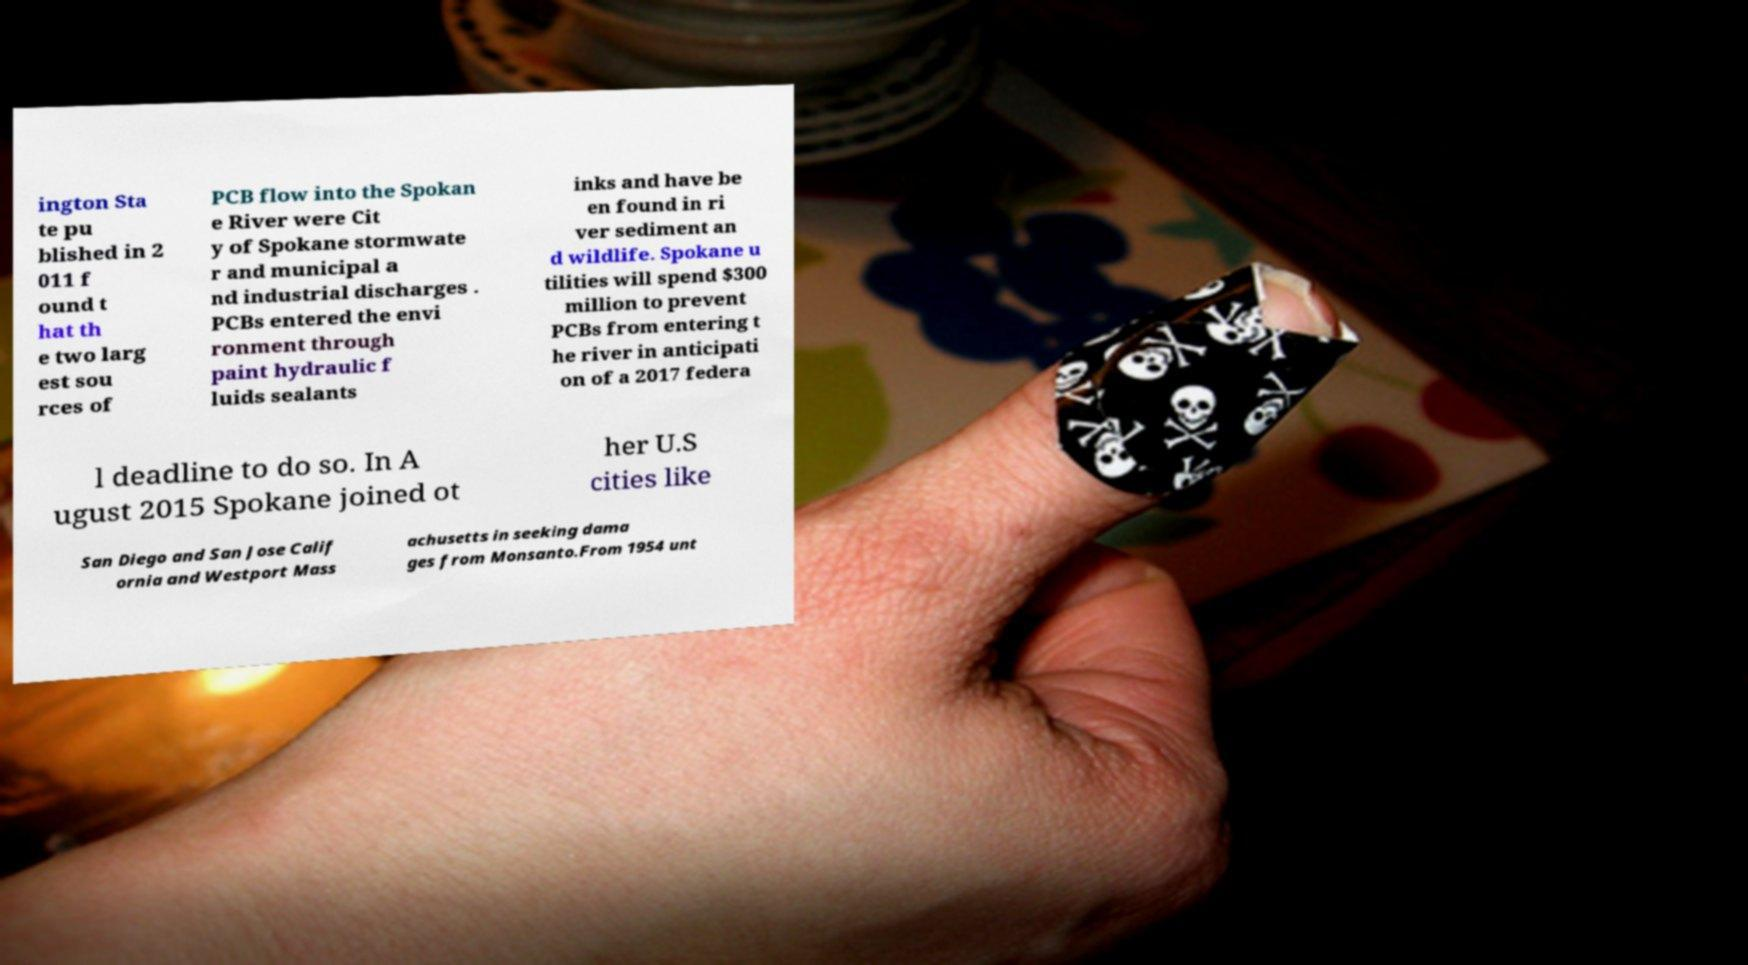Please identify and transcribe the text found in this image. ington Sta te pu blished in 2 011 f ound t hat th e two larg est sou rces of PCB flow into the Spokan e River were Cit y of Spokane stormwate r and municipal a nd industrial discharges . PCBs entered the envi ronment through paint hydraulic f luids sealants inks and have be en found in ri ver sediment an d wildlife. Spokane u tilities will spend $300 million to prevent PCBs from entering t he river in anticipati on of a 2017 federa l deadline to do so. In A ugust 2015 Spokane joined ot her U.S cities like San Diego and San Jose Calif ornia and Westport Mass achusetts in seeking dama ges from Monsanto.From 1954 unt 